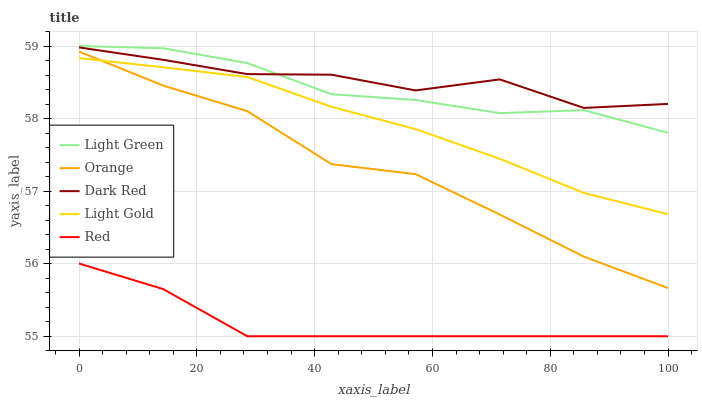Does Red have the minimum area under the curve?
Answer yes or no. Yes. Does Dark Red have the maximum area under the curve?
Answer yes or no. Yes. Does Light Gold have the minimum area under the curve?
Answer yes or no. No. Does Light Gold have the maximum area under the curve?
Answer yes or no. No. Is Light Gold the smoothest?
Answer yes or no. Yes. Is Dark Red the roughest?
Answer yes or no. Yes. Is Dark Red the smoothest?
Answer yes or no. No. Is Light Gold the roughest?
Answer yes or no. No. Does Light Gold have the lowest value?
Answer yes or no. No. Does Dark Red have the highest value?
Answer yes or no. No. Is Red less than Orange?
Answer yes or no. Yes. Is Orange greater than Red?
Answer yes or no. Yes. Does Red intersect Orange?
Answer yes or no. No. 